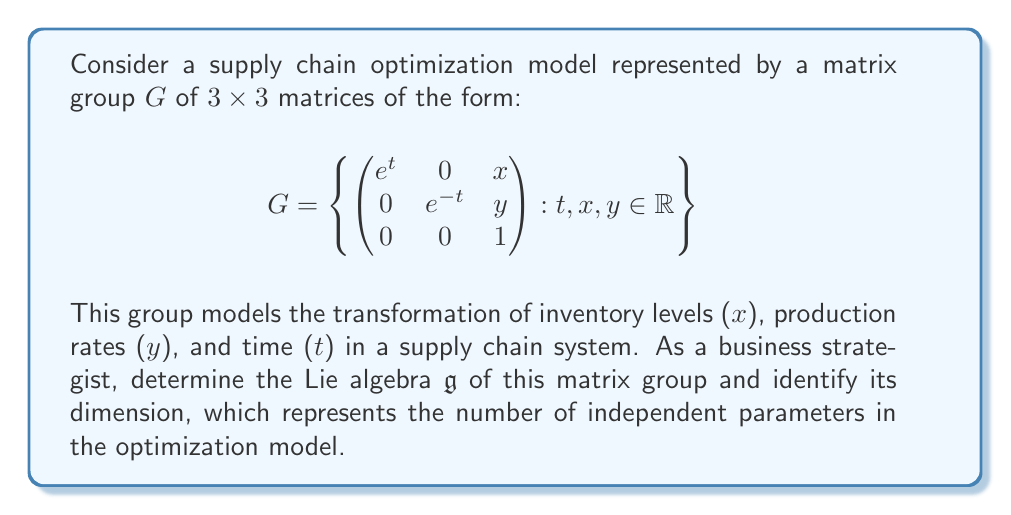Show me your answer to this math problem. To determine the Lie algebra of the matrix group G, we follow these steps:

1) The Lie algebra $\mathfrak{g}$ consists of all matrices X such that $e^{tX} \in G$ for all real t.

2) Let's consider a general element of $\mathfrak{g}$:

   $$X = \begin{pmatrix}
   a & b & c \\
   d & e & f \\
   g & h & i
   \end{pmatrix}$$

3) We need $e^{tX}$ to have the form of elements in G for all t. This means:

   $$e^{tX} = \begin{pmatrix}
   e^t & 0 & x \\
   0 & e^{-t} & y \\
   0 & 0 & 1
   \end{pmatrix}$$

4) Comparing the exponential series of $e^{tX}$ with the required form, we can deduce:

   - The (1,1) entry must be $e^t$, so $a = 1$ and $b = d = 0$
   - The (2,2) entry must be $e^{-t}$, so $e = -1$ and $f = h = 0$
   - The (3,3) entry must be 1, so $i = 0$
   - The (1,3) and (2,3) entries can be any real numbers, so $c$ and $f$ are free parameters
   - All other entries must be 0

5) Therefore, the general form of elements in $\mathfrak{g}$ is:

   $$X = \begin{pmatrix}
   1 & 0 & c \\
   0 & -1 & f \\
   0 & 0 & 0
   \end{pmatrix}$$

6) We can express this as a linear combination of basis elements:

   $$X = \begin{pmatrix}
   1 & 0 & 0 \\
   0 & -1 & 0 \\
   0 & 0 & 0
   \end{pmatrix} + c\begin{pmatrix}
   0 & 0 & 1 \\
   0 & 0 & 0 \\
   0 & 0 & 0
   \end{pmatrix} + f\begin{pmatrix}
   0 & 0 & 0 \\
   0 & 0 & 1 \\
   0 & 0 & 0
   \end{pmatrix}$$

7) The dimension of $\mathfrak{g}$ is the number of independent parameters, which is 3 (corresponding to t, x, and y in the original group).
Answer: The Lie algebra $\mathfrak{g}$ consists of matrices of the form $\begin{pmatrix}
1 & 0 & c \\
0 & -1 & f \\
0 & 0 & 0
\end{pmatrix}$ where $c, f \in \mathbb{R}$, and its dimension is 3. 